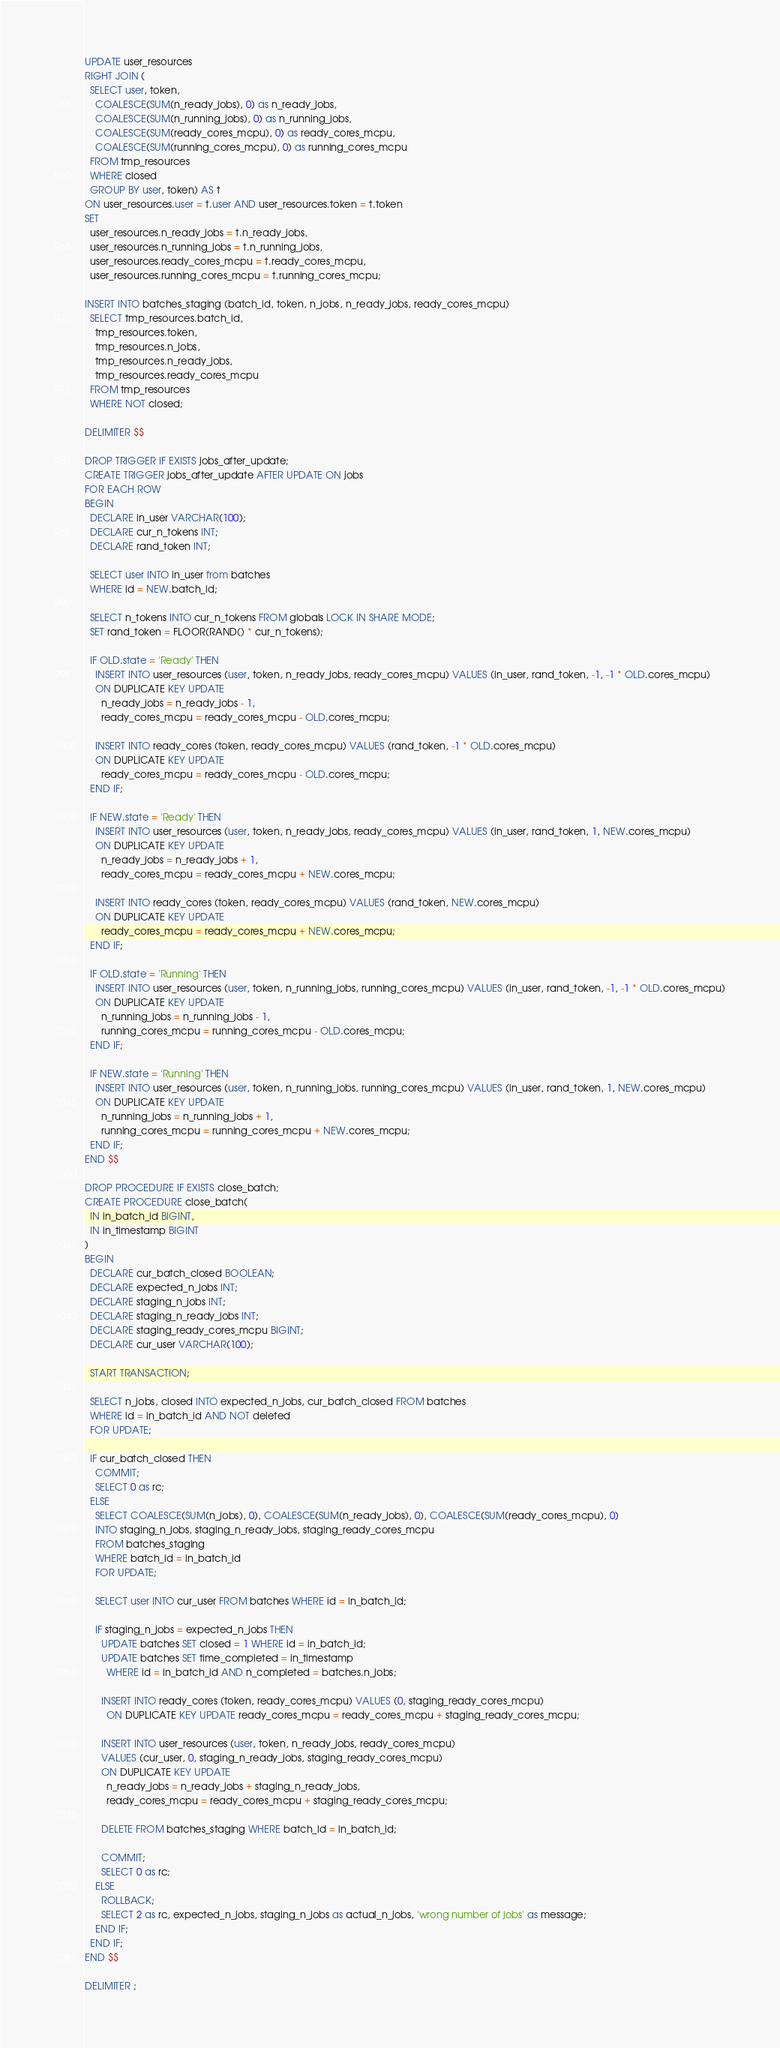Convert code to text. <code><loc_0><loc_0><loc_500><loc_500><_SQL_>UPDATE user_resources
RIGHT JOIN (
  SELECT user, token,
    COALESCE(SUM(n_ready_jobs), 0) as n_ready_jobs,
    COALESCE(SUM(n_running_jobs), 0) as n_running_jobs,
    COALESCE(SUM(ready_cores_mcpu), 0) as ready_cores_mcpu,
    COALESCE(SUM(running_cores_mcpu), 0) as running_cores_mcpu
  FROM tmp_resources
  WHERE closed
  GROUP BY user, token) AS t
ON user_resources.user = t.user AND user_resources.token = t.token
SET
  user_resources.n_ready_jobs = t.n_ready_jobs,
  user_resources.n_running_jobs = t.n_running_jobs,
  user_resources.ready_cores_mcpu = t.ready_cores_mcpu,
  user_resources.running_cores_mcpu = t.running_cores_mcpu;

INSERT INTO batches_staging (batch_id, token, n_jobs, n_ready_jobs, ready_cores_mcpu)
  SELECT tmp_resources.batch_id,
    tmp_resources.token,
    tmp_resources.n_jobs,
    tmp_resources.n_ready_jobs,
    tmp_resources.ready_cores_mcpu
  FROM tmp_resources
  WHERE NOT closed;

DELIMITER $$

DROP TRIGGER IF EXISTS jobs_after_update;
CREATE TRIGGER jobs_after_update AFTER UPDATE ON jobs
FOR EACH ROW
BEGIN
  DECLARE in_user VARCHAR(100);
  DECLARE cur_n_tokens INT;
  DECLARE rand_token INT;

  SELECT user INTO in_user from batches
  WHERE id = NEW.batch_id;

  SELECT n_tokens INTO cur_n_tokens FROM globals LOCK IN SHARE MODE;
  SET rand_token = FLOOR(RAND() * cur_n_tokens);

  IF OLD.state = 'Ready' THEN
    INSERT INTO user_resources (user, token, n_ready_jobs, ready_cores_mcpu) VALUES (in_user, rand_token, -1, -1 * OLD.cores_mcpu)
    ON DUPLICATE KEY UPDATE
      n_ready_jobs = n_ready_jobs - 1,
      ready_cores_mcpu = ready_cores_mcpu - OLD.cores_mcpu;

    INSERT INTO ready_cores (token, ready_cores_mcpu) VALUES (rand_token, -1 * OLD.cores_mcpu)
    ON DUPLICATE KEY UPDATE
      ready_cores_mcpu = ready_cores_mcpu - OLD.cores_mcpu;
  END IF;

  IF NEW.state = 'Ready' THEN
    INSERT INTO user_resources (user, token, n_ready_jobs, ready_cores_mcpu) VALUES (in_user, rand_token, 1, NEW.cores_mcpu)
    ON DUPLICATE KEY UPDATE
      n_ready_jobs = n_ready_jobs + 1,
      ready_cores_mcpu = ready_cores_mcpu + NEW.cores_mcpu;

    INSERT INTO ready_cores (token, ready_cores_mcpu) VALUES (rand_token, NEW.cores_mcpu)
    ON DUPLICATE KEY UPDATE
      ready_cores_mcpu = ready_cores_mcpu + NEW.cores_mcpu;
  END IF;

  IF OLD.state = 'Running' THEN
    INSERT INTO user_resources (user, token, n_running_jobs, running_cores_mcpu) VALUES (in_user, rand_token, -1, -1 * OLD.cores_mcpu)
    ON DUPLICATE KEY UPDATE
      n_running_jobs = n_running_jobs - 1,
      running_cores_mcpu = running_cores_mcpu - OLD.cores_mcpu;
  END IF;

  IF NEW.state = 'Running' THEN
    INSERT INTO user_resources (user, token, n_running_jobs, running_cores_mcpu) VALUES (in_user, rand_token, 1, NEW.cores_mcpu)
    ON DUPLICATE KEY UPDATE
      n_running_jobs = n_running_jobs + 1,
      running_cores_mcpu = running_cores_mcpu + NEW.cores_mcpu;
  END IF;
END $$

DROP PROCEDURE IF EXISTS close_batch;
CREATE PROCEDURE close_batch(
  IN in_batch_id BIGINT,
  IN in_timestamp BIGINT
)
BEGIN
  DECLARE cur_batch_closed BOOLEAN;
  DECLARE expected_n_jobs INT;
  DECLARE staging_n_jobs INT;
  DECLARE staging_n_ready_jobs INT;
  DECLARE staging_ready_cores_mcpu BIGINT;
  DECLARE cur_user VARCHAR(100);

  START TRANSACTION;

  SELECT n_jobs, closed INTO expected_n_jobs, cur_batch_closed FROM batches
  WHERE id = in_batch_id AND NOT deleted
  FOR UPDATE;

  IF cur_batch_closed THEN
    COMMIT;
    SELECT 0 as rc;
  ELSE
    SELECT COALESCE(SUM(n_jobs), 0), COALESCE(SUM(n_ready_jobs), 0), COALESCE(SUM(ready_cores_mcpu), 0)
    INTO staging_n_jobs, staging_n_ready_jobs, staging_ready_cores_mcpu
    FROM batches_staging
    WHERE batch_id = in_batch_id
    FOR UPDATE;

    SELECT user INTO cur_user FROM batches WHERE id = in_batch_id;

    IF staging_n_jobs = expected_n_jobs THEN
      UPDATE batches SET closed = 1 WHERE id = in_batch_id;
      UPDATE batches SET time_completed = in_timestamp
        WHERE id = in_batch_id AND n_completed = batches.n_jobs;

      INSERT INTO ready_cores (token, ready_cores_mcpu) VALUES (0, staging_ready_cores_mcpu)
        ON DUPLICATE KEY UPDATE ready_cores_mcpu = ready_cores_mcpu + staging_ready_cores_mcpu;

      INSERT INTO user_resources (user, token, n_ready_jobs, ready_cores_mcpu)
      VALUES (cur_user, 0, staging_n_ready_jobs, staging_ready_cores_mcpu)
      ON DUPLICATE KEY UPDATE
        n_ready_jobs = n_ready_jobs + staging_n_ready_jobs,
        ready_cores_mcpu = ready_cores_mcpu + staging_ready_cores_mcpu;

      DELETE FROM batches_staging WHERE batch_id = in_batch_id;

      COMMIT;
      SELECT 0 as rc;
    ELSE
      ROLLBACK;
      SELECT 2 as rc, expected_n_jobs, staging_n_jobs as actual_n_jobs, 'wrong number of jobs' as message;
    END IF;
  END IF;
END $$

DELIMITER ;
</code> 